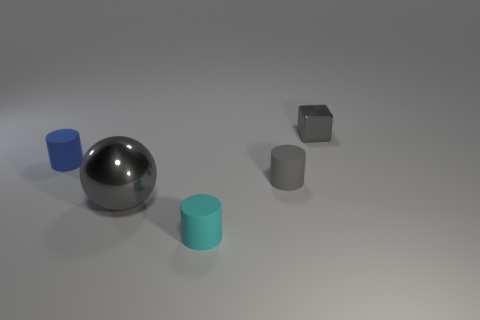Is there any other thing that has the same size as the cyan object?
Offer a terse response. Yes. There is a thing that is made of the same material as the tiny gray cube; what color is it?
Keep it short and to the point. Gray. How many balls are either large gray objects or purple matte objects?
Your response must be concise. 1. What number of objects are either tiny gray metallic objects or rubber things in front of the small blue matte thing?
Provide a short and direct response. 3. Is there a gray shiny ball?
Your answer should be very brief. Yes. What number of metal cubes are the same color as the ball?
Offer a terse response. 1. There is a tiny object that is the same color as the cube; what is its material?
Keep it short and to the point. Rubber. There is a metallic thing in front of the gray object behind the small blue matte cylinder; what size is it?
Ensure brevity in your answer.  Large. Is there a tiny gray cube made of the same material as the cyan thing?
Make the answer very short. No. There is another gray object that is the same size as the gray rubber object; what material is it?
Keep it short and to the point. Metal. 